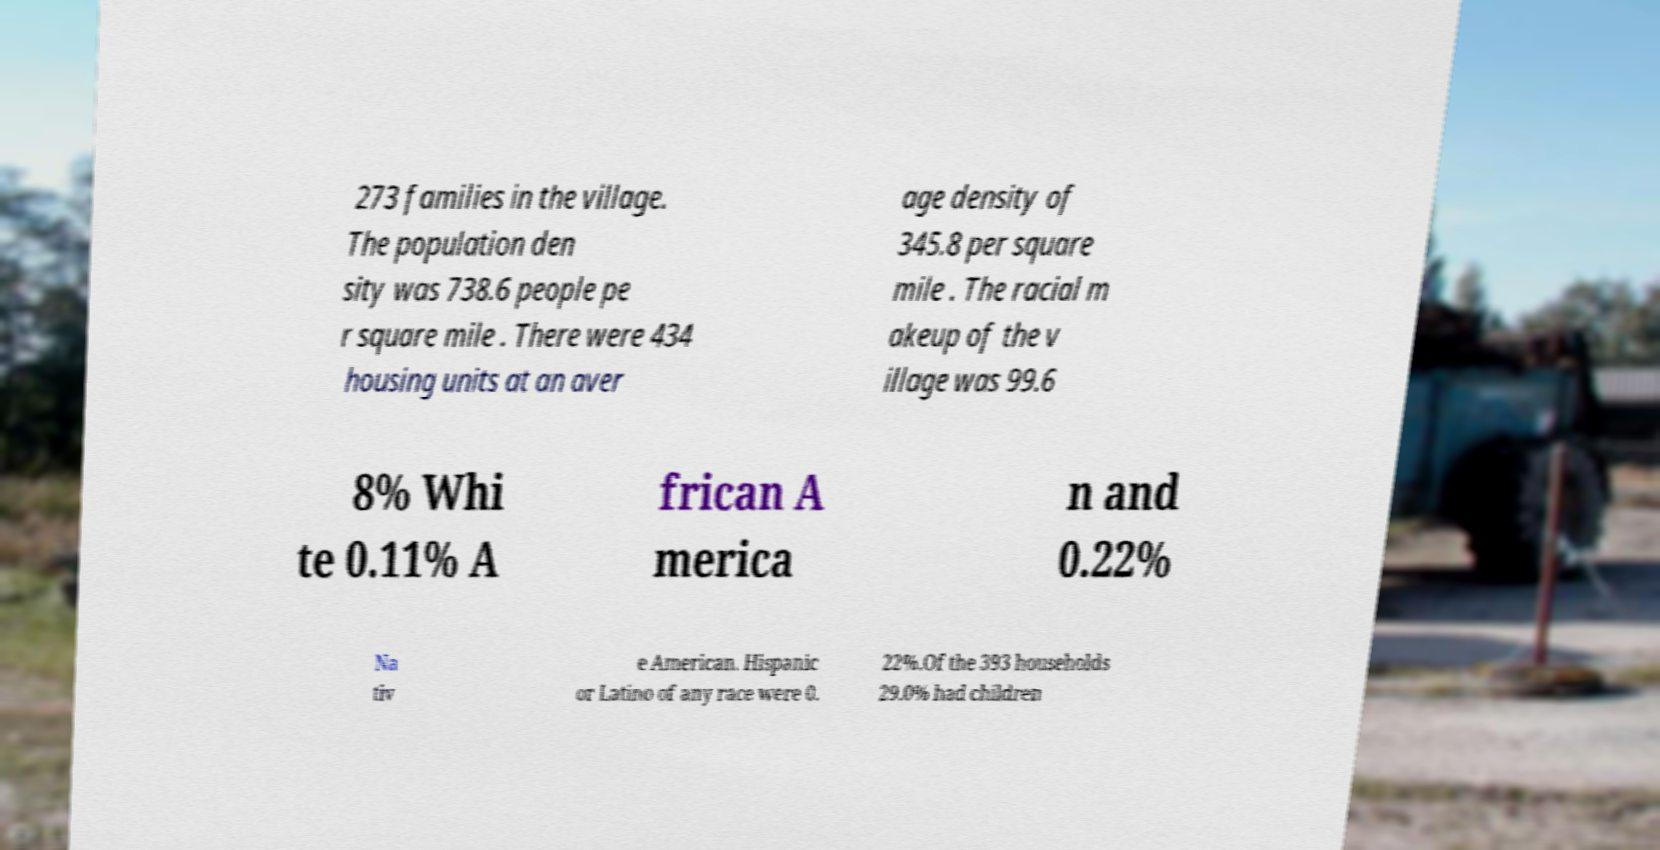Could you assist in decoding the text presented in this image and type it out clearly? 273 families in the village. The population den sity was 738.6 people pe r square mile . There were 434 housing units at an aver age density of 345.8 per square mile . The racial m akeup of the v illage was 99.6 8% Whi te 0.11% A frican A merica n and 0.22% Na tiv e American. Hispanic or Latino of any race were 0. 22%.Of the 393 households 29.0% had children 